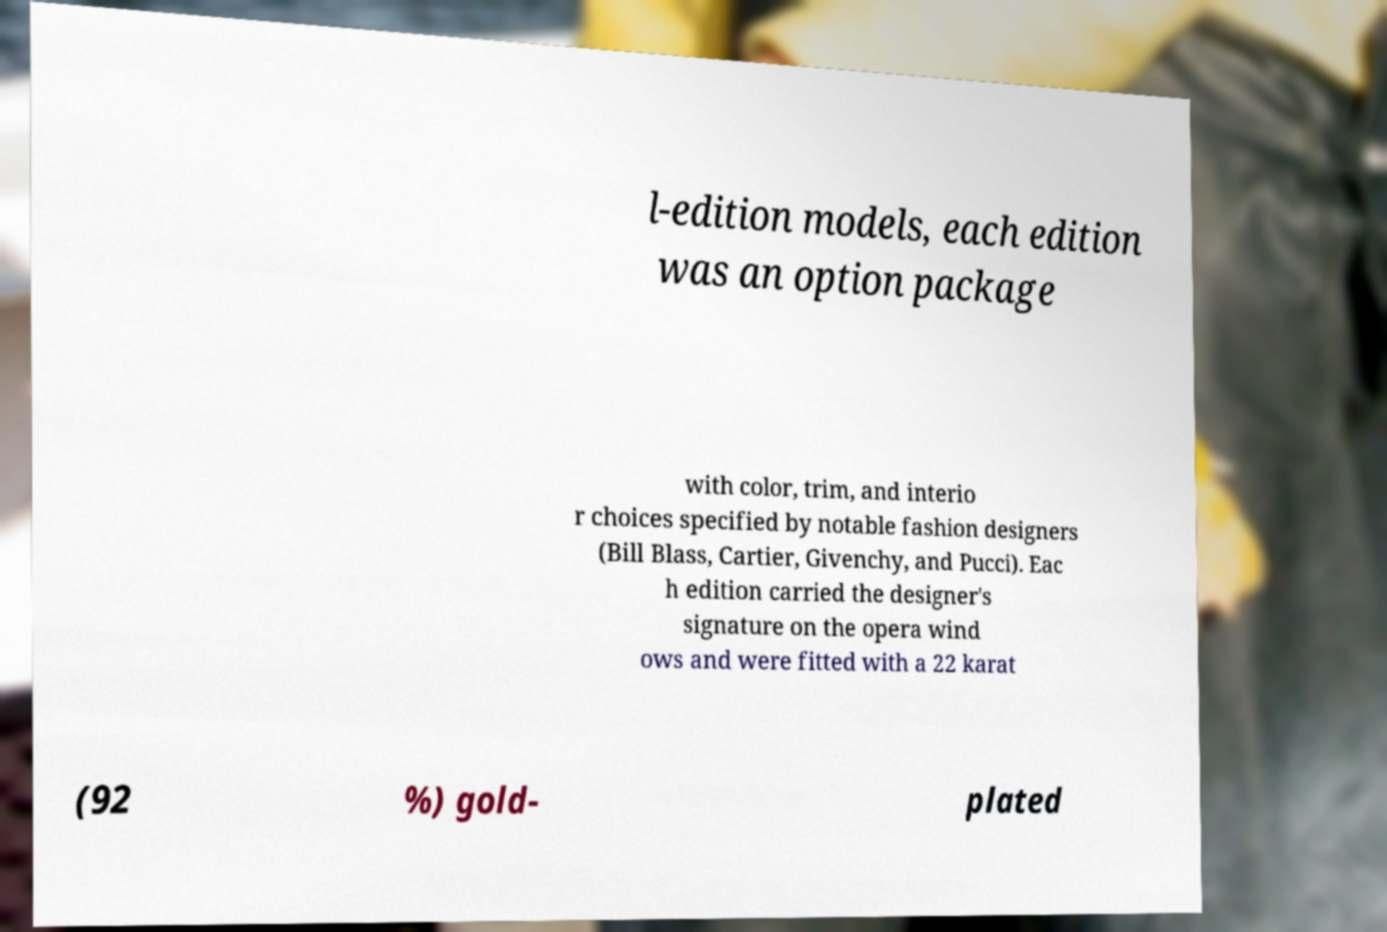Can you accurately transcribe the text from the provided image for me? l-edition models, each edition was an option package with color, trim, and interio r choices specified by notable fashion designers (Bill Blass, Cartier, Givenchy, and Pucci). Eac h edition carried the designer's signature on the opera wind ows and were fitted with a 22 karat (92 %) gold- plated 